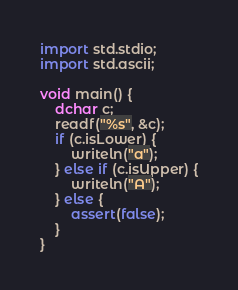<code> <loc_0><loc_0><loc_500><loc_500><_D_>import std.stdio;
import std.ascii;

void main() {
	dchar c;
	readf("%s", &c);
	if (c.isLower) {
		writeln("a");
	} else if (c.isUpper) {
		writeln("A");
	} else {
		assert(false);
	}
}
</code> 